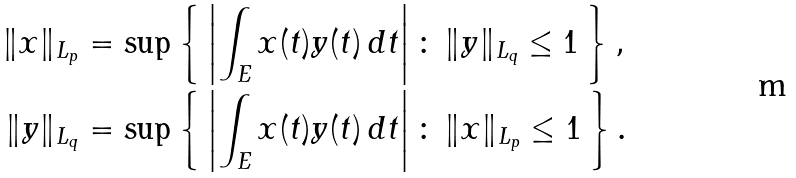<formula> <loc_0><loc_0><loc_500><loc_500>\| x \| _ { L _ { p } } & = \sup \left \{ \, \left | \int _ { E } x ( t ) y ( t ) \, d t \right | \colon \, \| y \| _ { L _ { q } } \leq 1 \, \right \} , \\ \| y \| _ { L _ { q } } & = \sup \left \{ \, \left | \int _ { E } x ( t ) y ( t ) \, d t \right | \colon \, \| x \| _ { L _ { p } } \leq 1 \, \right \} .</formula> 